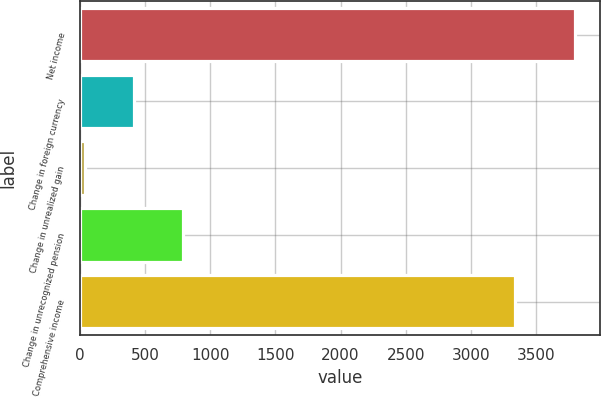<chart> <loc_0><loc_0><loc_500><loc_500><bar_chart><fcel>Net income<fcel>Change in foreign currency<fcel>Change in unrealized gain<fcel>Change in unrecognized pension<fcel>Comprehensive income<nl><fcel>3804<fcel>411.9<fcel>35<fcel>788.8<fcel>3336<nl></chart> 